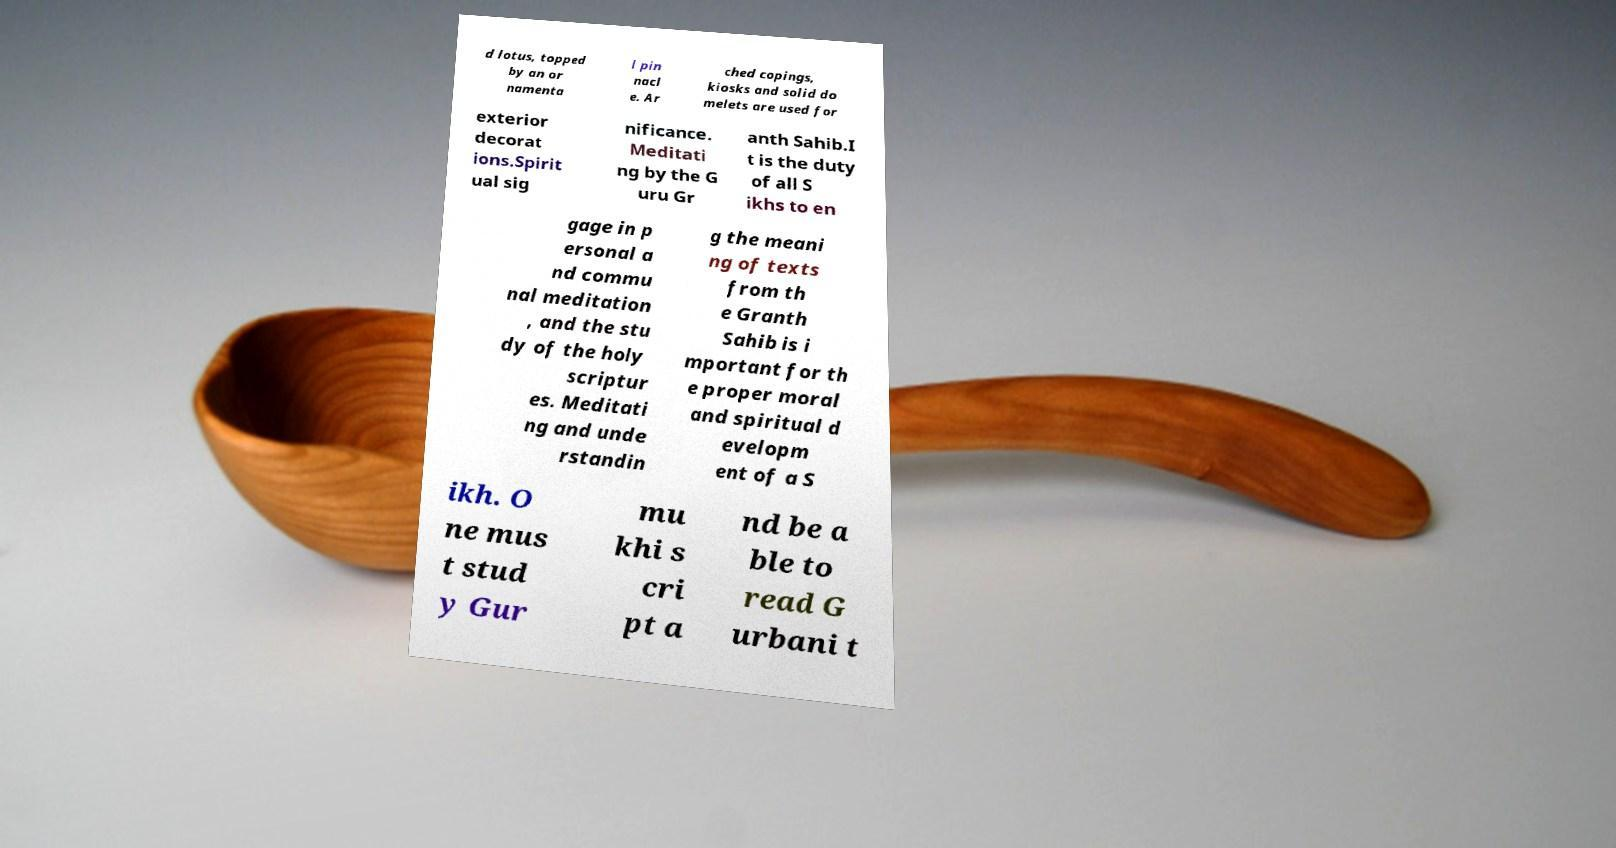Can you accurately transcribe the text from the provided image for me? d lotus, topped by an or namenta l pin nacl e. Ar ched copings, kiosks and solid do melets are used for exterior decorat ions.Spirit ual sig nificance. Meditati ng by the G uru Gr anth Sahib.I t is the duty of all S ikhs to en gage in p ersonal a nd commu nal meditation , and the stu dy of the holy scriptur es. Meditati ng and unde rstandin g the meani ng of texts from th e Granth Sahib is i mportant for th e proper moral and spiritual d evelopm ent of a S ikh. O ne mus t stud y Gur mu khi s cri pt a nd be a ble to read G urbani t 